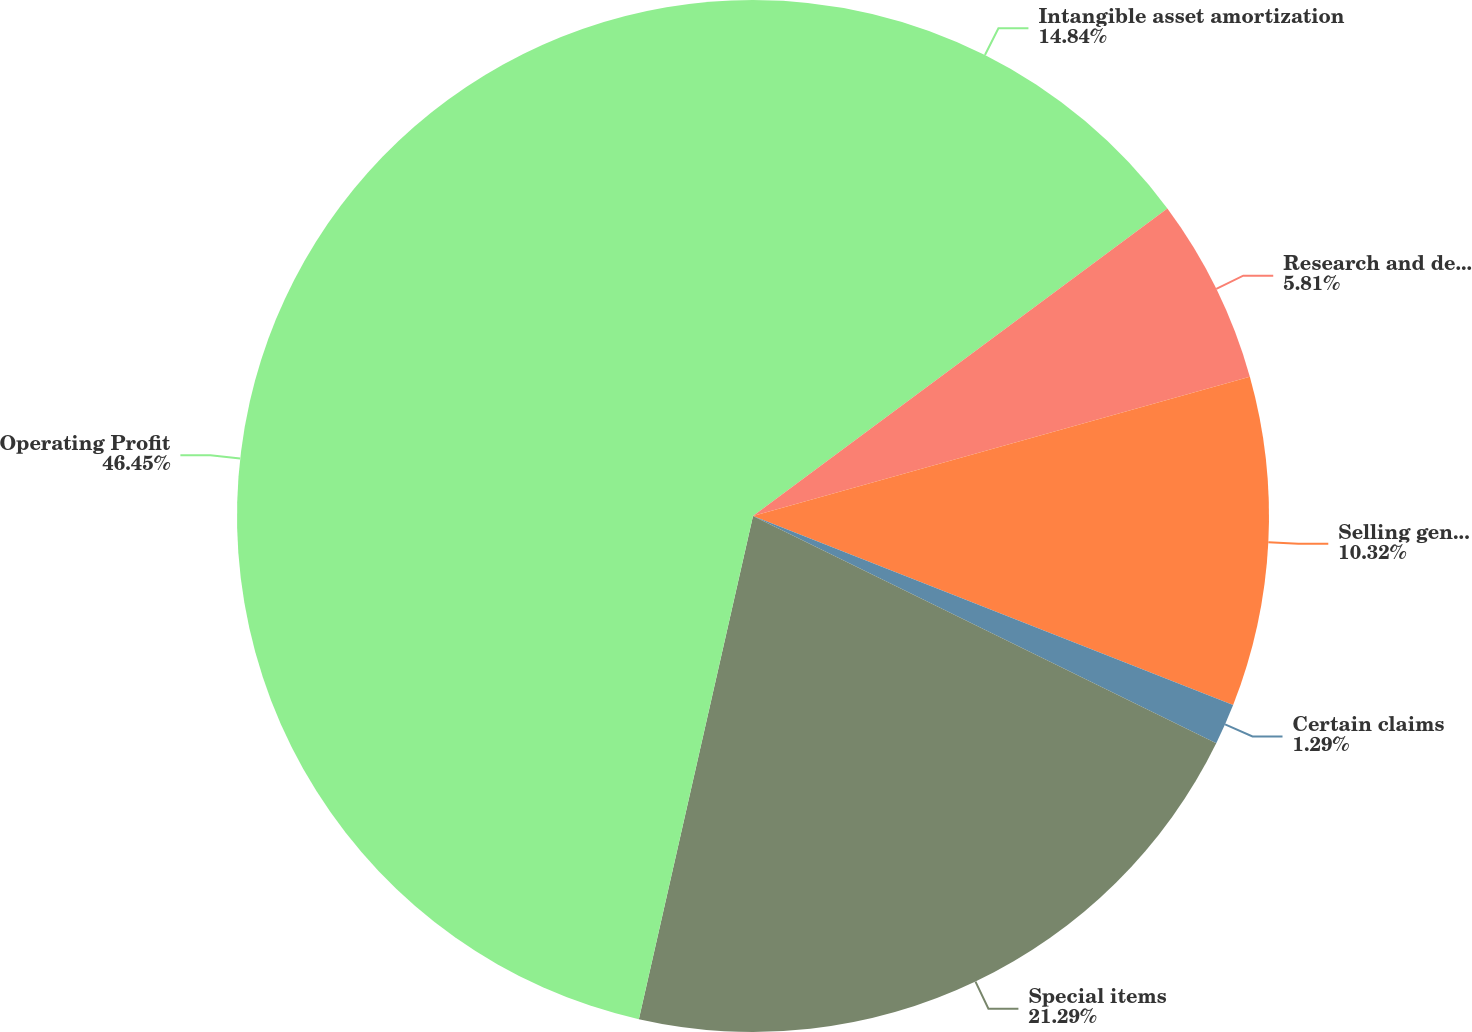Convert chart. <chart><loc_0><loc_0><loc_500><loc_500><pie_chart><fcel>Intangible asset amortization<fcel>Research and development<fcel>Selling general and<fcel>Certain claims<fcel>Special items<fcel>Operating Profit<nl><fcel>14.84%<fcel>5.81%<fcel>10.32%<fcel>1.29%<fcel>21.29%<fcel>46.45%<nl></chart> 